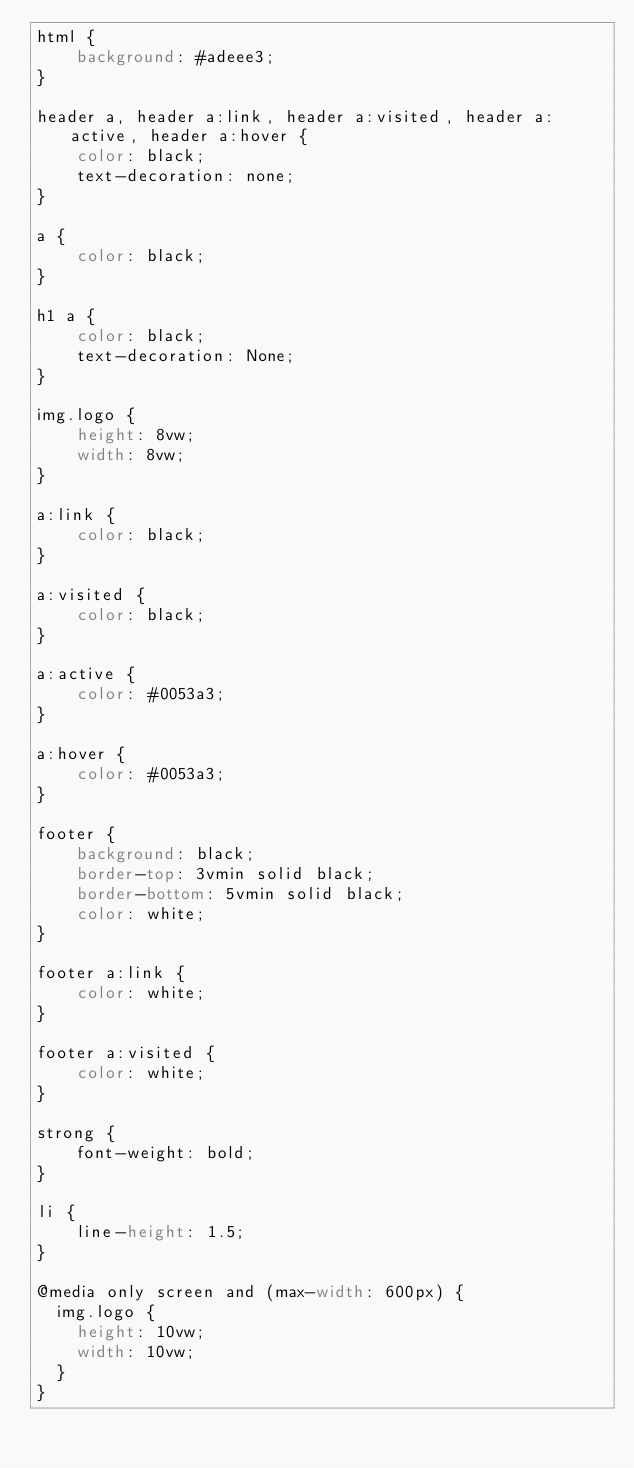<code> <loc_0><loc_0><loc_500><loc_500><_CSS_>html {
    background: #adeee3;
}

header a, header a:link, header a:visited, header a:active, header a:hover {
    color: black;
    text-decoration: none;
}

a {
    color: black;
}

h1 a {
    color: black;
    text-decoration: None;
}

img.logo {
    height: 8vw;
    width: 8vw;
}

a:link {
    color: black;
}

a:visited {
    color: black;
}

a:active {
    color: #0053a3;
}

a:hover {
    color: #0053a3;
}

footer {
    background: black;
    border-top: 3vmin solid black;
    border-bottom: 5vmin solid black;
    color: white;
}

footer a:link {
    color: white;
}

footer a:visited {
    color: white;
}

strong {
    font-weight: bold;
}

li {
    line-height: 1.5;
}

@media only screen and (max-width: 600px) {
  img.logo {
    height: 10vw;
    width: 10vw;
  }
}
</code> 